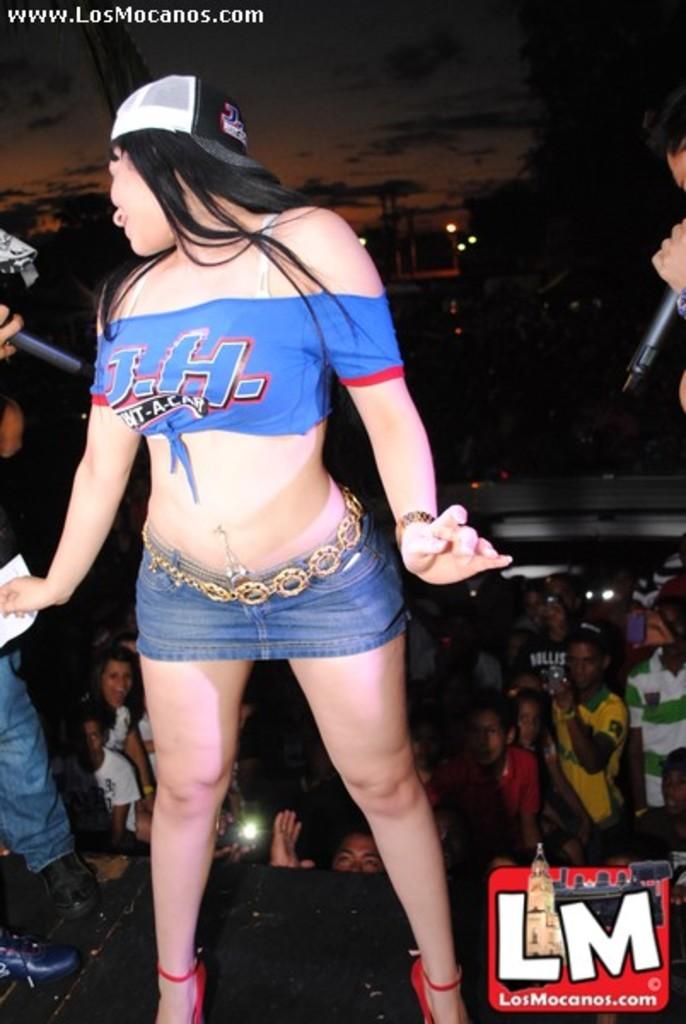What business was this picture taken at?
Offer a very short reply. Losmocanos. 